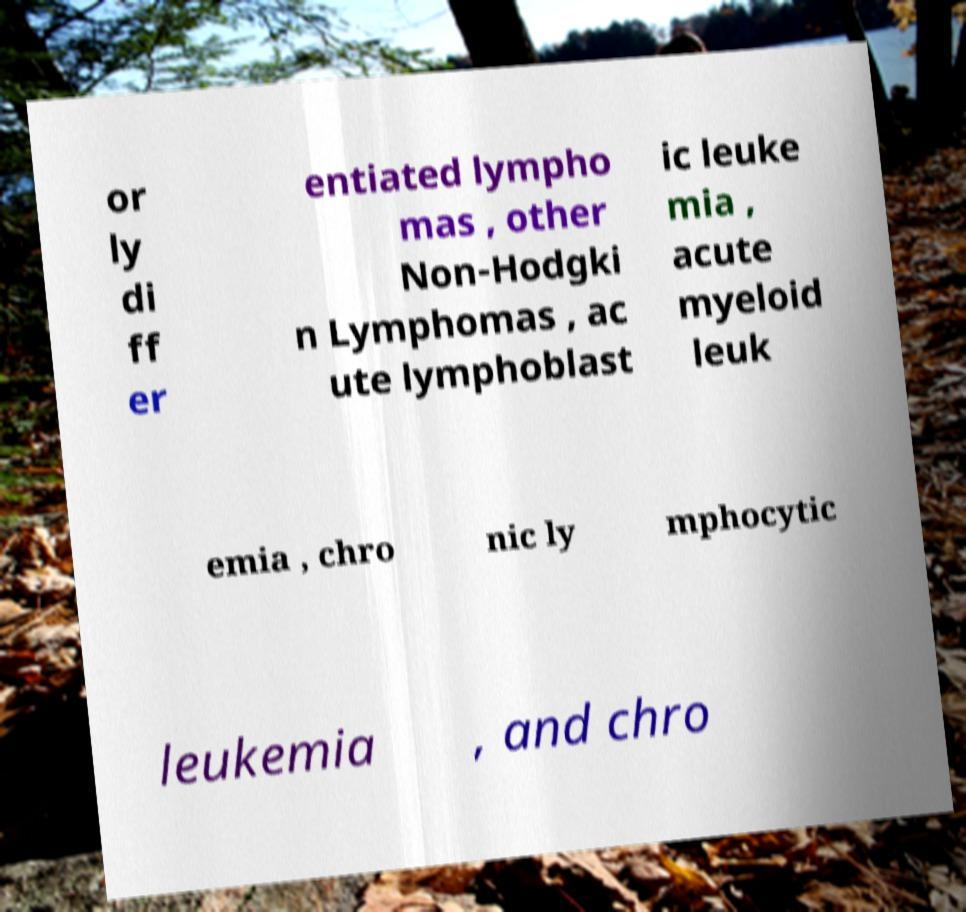I need the written content from this picture converted into text. Can you do that? or ly di ff er entiated lympho mas , other Non-Hodgki n Lymphomas , ac ute lymphoblast ic leuke mia , acute myeloid leuk emia , chro nic ly mphocytic leukemia , and chro 